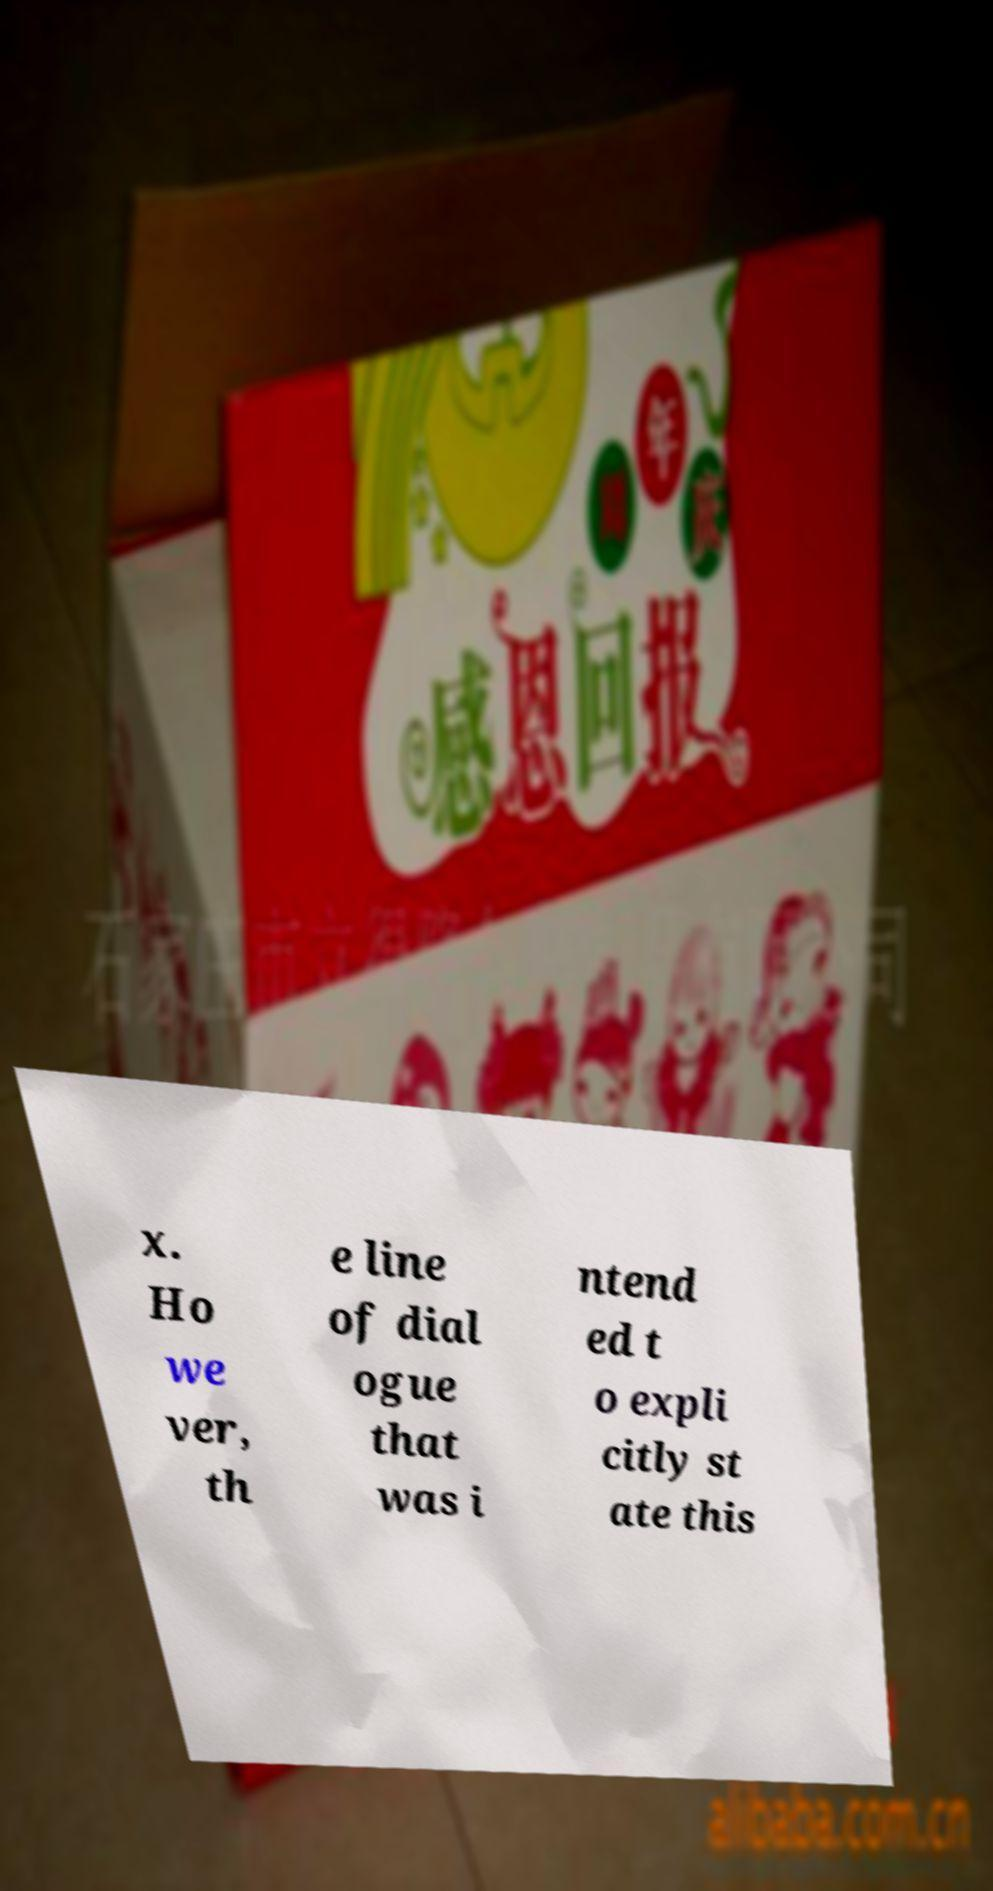For documentation purposes, I need the text within this image transcribed. Could you provide that? x. Ho we ver, th e line of dial ogue that was i ntend ed t o expli citly st ate this 